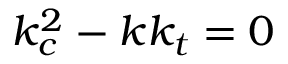Convert formula to latex. <formula><loc_0><loc_0><loc_500><loc_500>k _ { c } ^ { 2 } - k k _ { t } = 0</formula> 